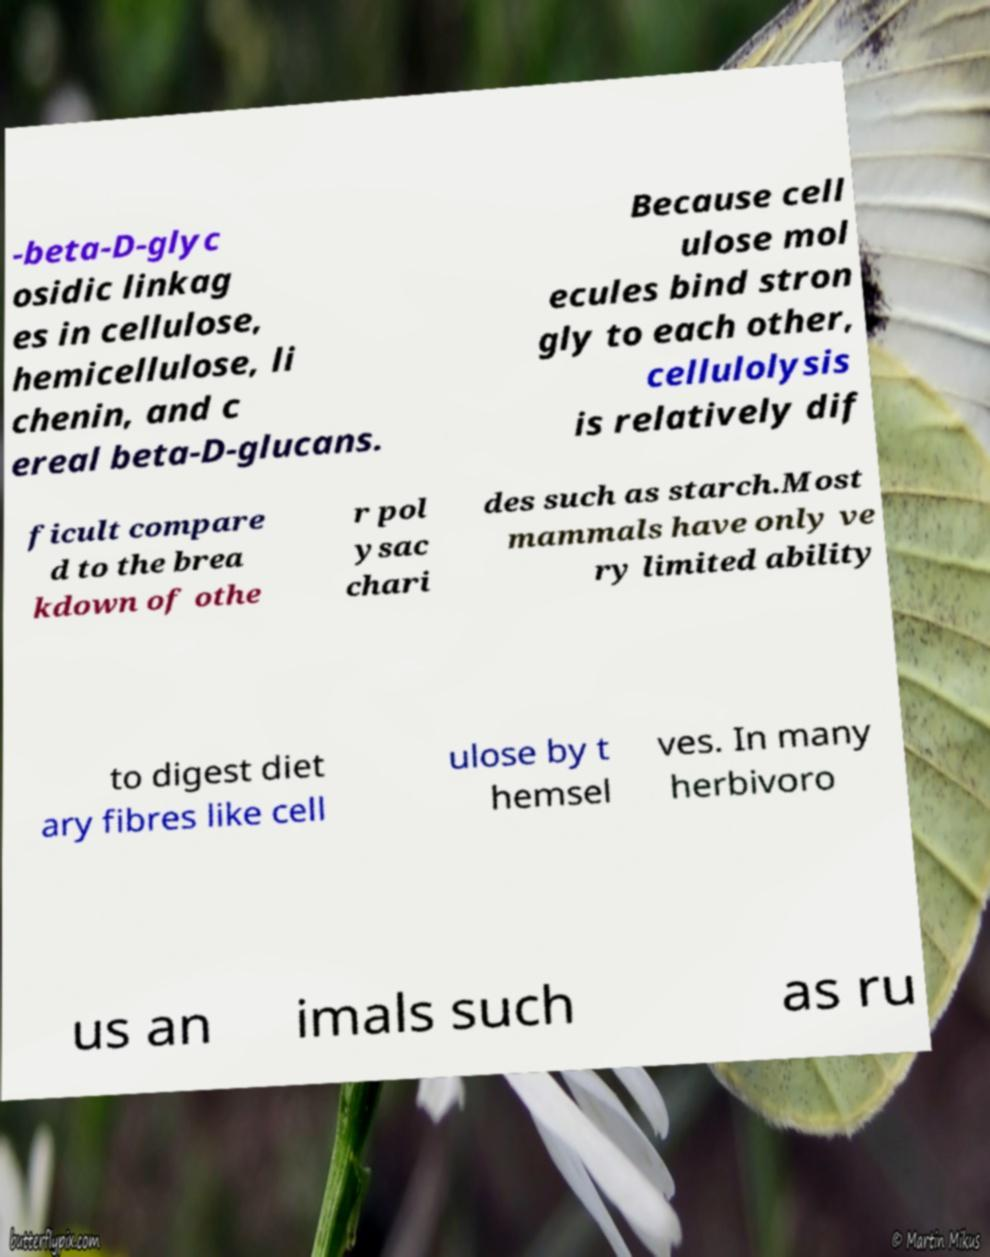What messages or text are displayed in this image? I need them in a readable, typed format. -beta-D-glyc osidic linkag es in cellulose, hemicellulose, li chenin, and c ereal beta-D-glucans. Because cell ulose mol ecules bind stron gly to each other, cellulolysis is relatively dif ficult compare d to the brea kdown of othe r pol ysac chari des such as starch.Most mammals have only ve ry limited ability to digest diet ary fibres like cell ulose by t hemsel ves. In many herbivoro us an imals such as ru 